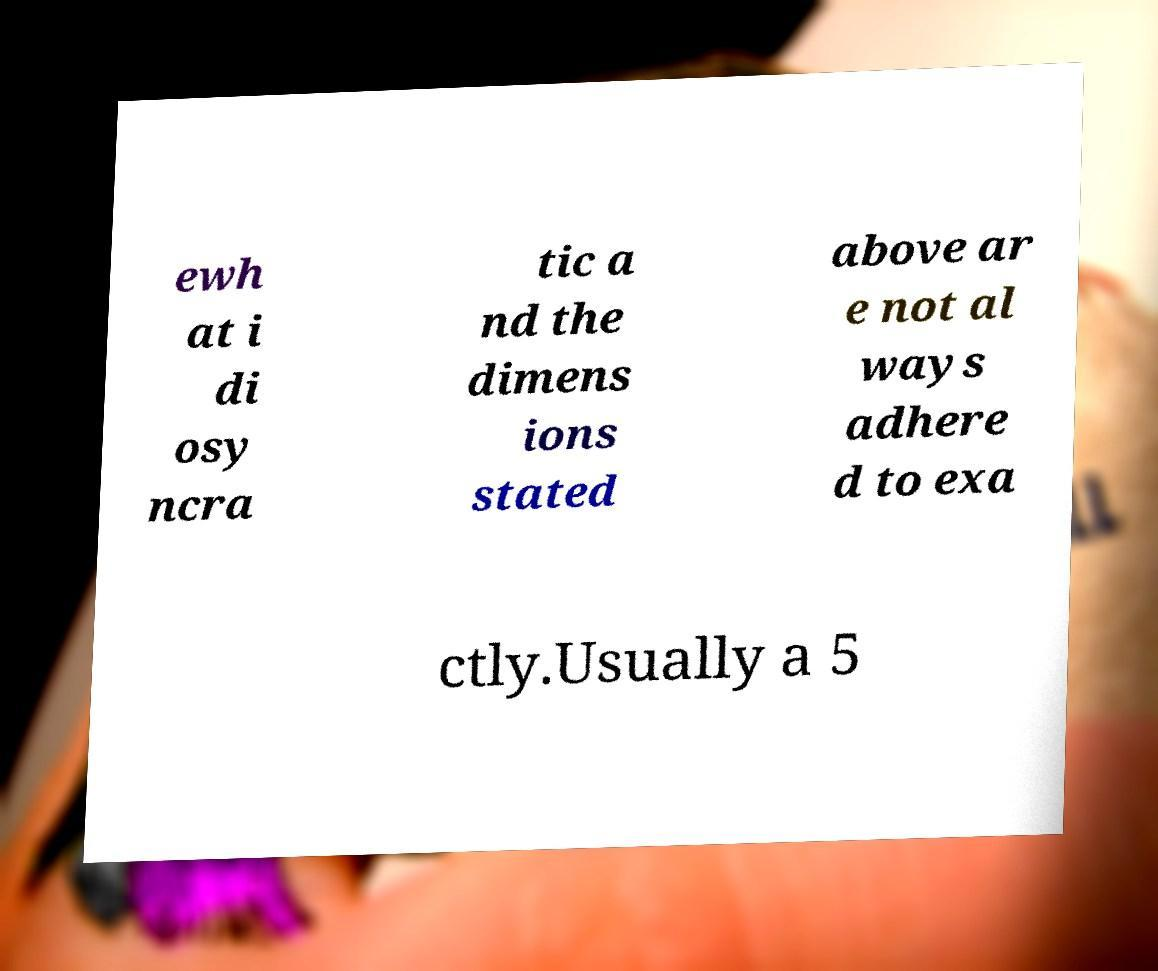There's text embedded in this image that I need extracted. Can you transcribe it verbatim? ewh at i di osy ncra tic a nd the dimens ions stated above ar e not al ways adhere d to exa ctly.Usually a 5 